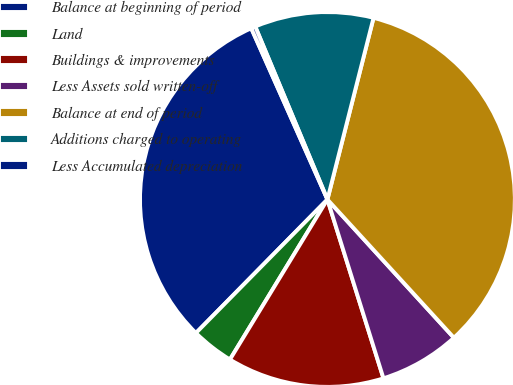Convert chart to OTSL. <chart><loc_0><loc_0><loc_500><loc_500><pie_chart><fcel>Balance at beginning of period<fcel>Land<fcel>Buildings & improvements<fcel>Less Assets sold written-off<fcel>Balance at end of period<fcel>Additions charged to operating<fcel>Less Accumulated depreciation<nl><fcel>30.96%<fcel>3.67%<fcel>13.54%<fcel>6.96%<fcel>34.25%<fcel>10.25%<fcel>0.37%<nl></chart> 